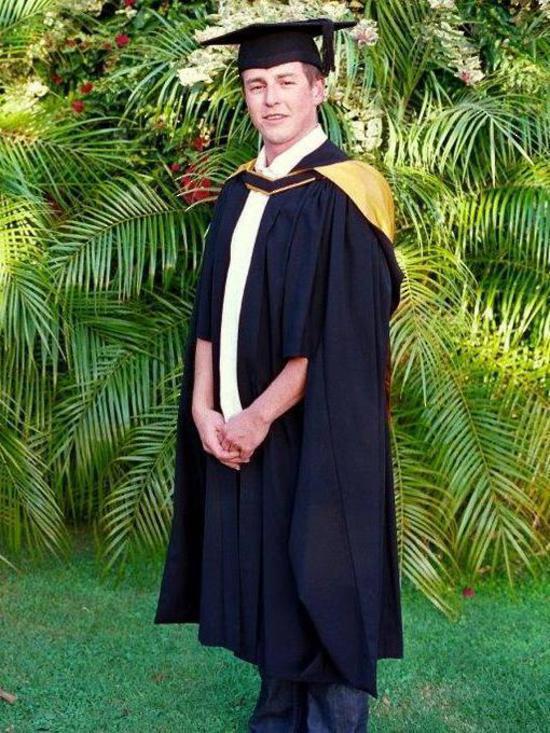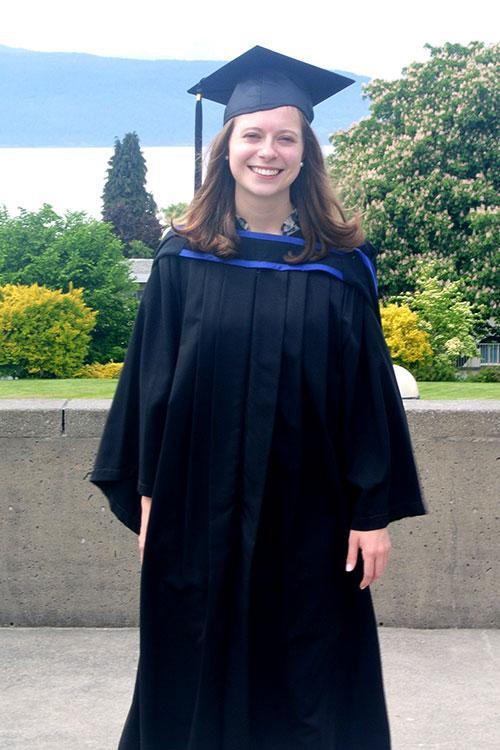The first image is the image on the left, the second image is the image on the right. Analyze the images presented: Is the assertion "In the right image, the tassle of a graduate's hat is on the left side of the image." valid? Answer yes or no. Yes. The first image is the image on the left, the second image is the image on the right. Examine the images to the left and right. Is the description "Each image contains one female graduate, and one image shows a graduate who is not facing forward." accurate? Answer yes or no. No. 